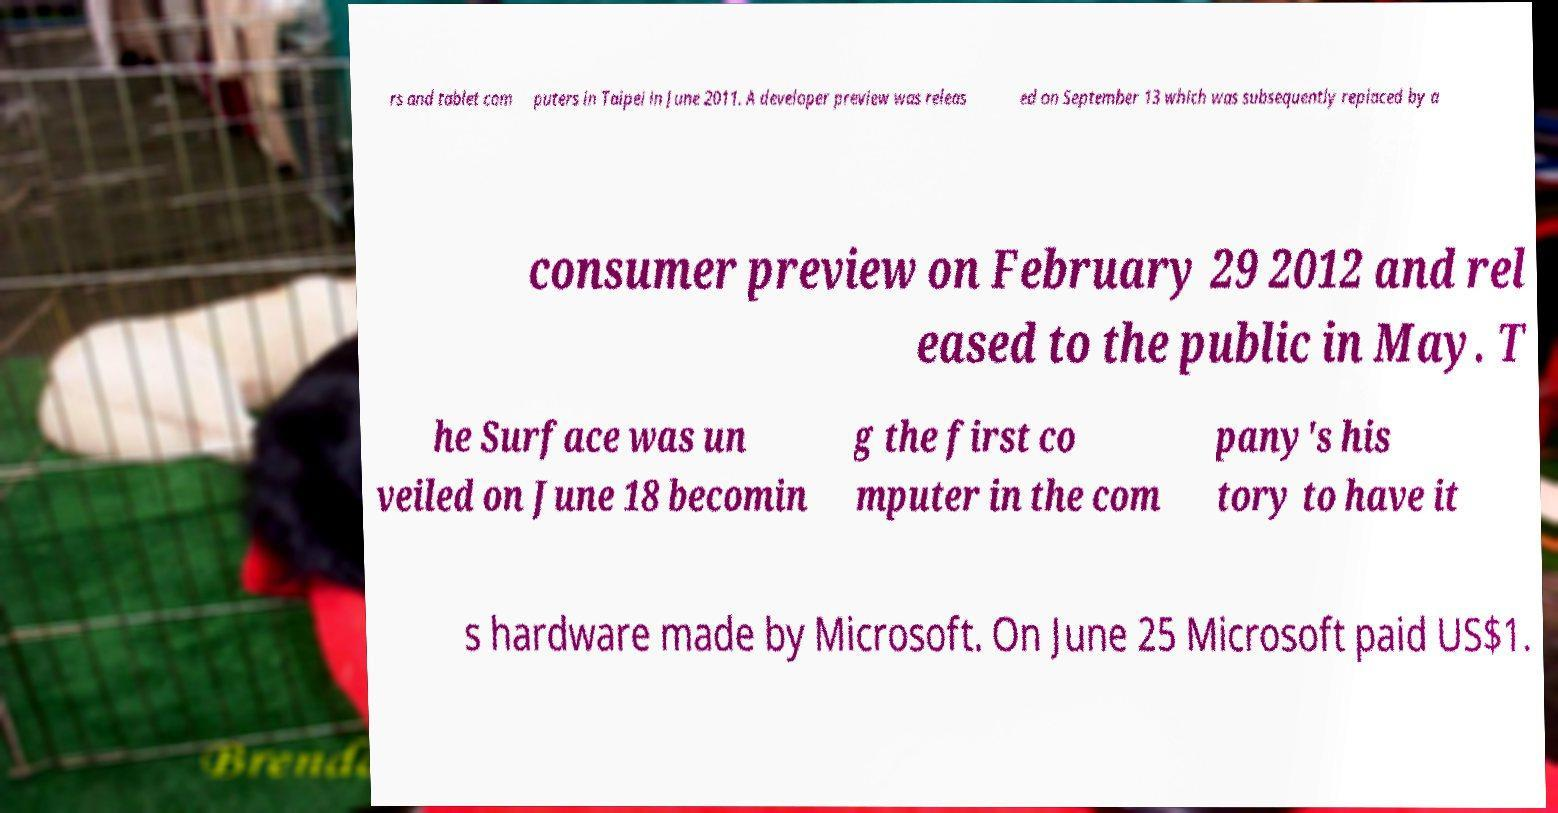What messages or text are displayed in this image? I need them in a readable, typed format. rs and tablet com puters in Taipei in June 2011. A developer preview was releas ed on September 13 which was subsequently replaced by a consumer preview on February 29 2012 and rel eased to the public in May. T he Surface was un veiled on June 18 becomin g the first co mputer in the com pany's his tory to have it s hardware made by Microsoft. On June 25 Microsoft paid US$1. 